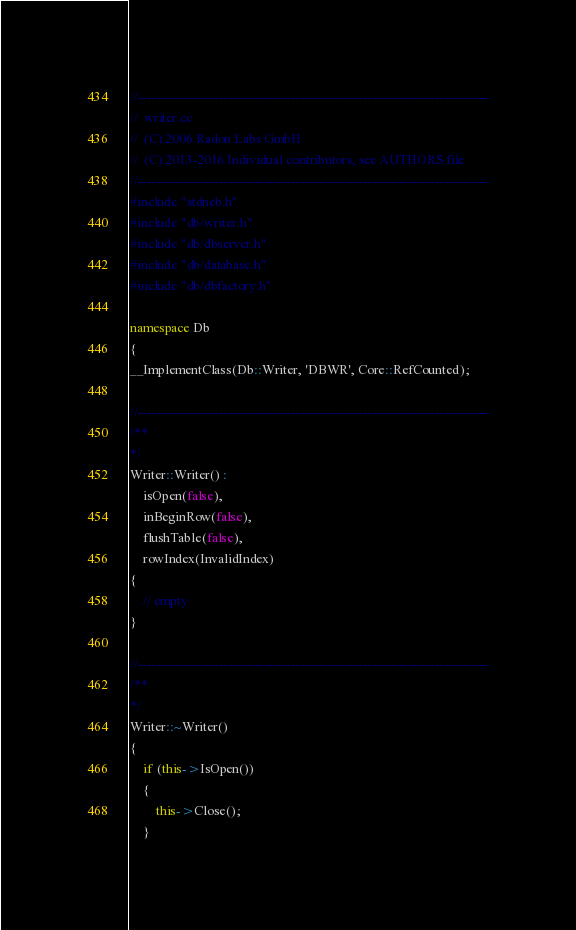<code> <loc_0><loc_0><loc_500><loc_500><_C++_>//------------------------------------------------------------------------------
//  writer.cc
//  (C) 2006 Radon Labs GmbH
//  (C) 2013-2016 Individual contributors, see AUTHORS file
//------------------------------------------------------------------------------
#include "stdneb.h"
#include "db/writer.h"
#include "db/dbserver.h"
#include "db/database.h"
#include "db/dbfactory.h"

namespace Db
{
__ImplementClass(Db::Writer, 'DBWR', Core::RefCounted);

//------------------------------------------------------------------------------
/**
*/
Writer::Writer() :
    isOpen(false),
    inBeginRow(false),
    flushTable(false),
    rowIndex(InvalidIndex)
{
    // empty
}

//------------------------------------------------------------------------------
/**
*/
Writer::~Writer()
{
    if (this->IsOpen())
    {
        this->Close();
    }</code> 